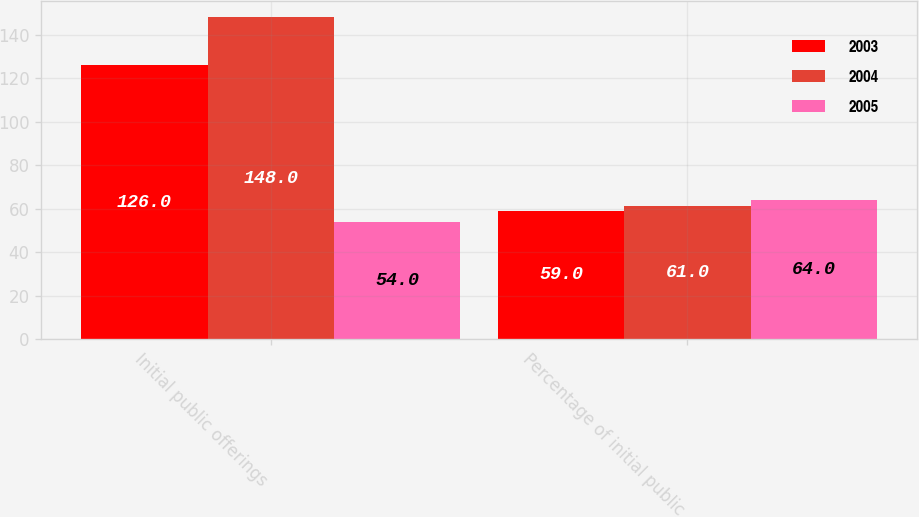Convert chart to OTSL. <chart><loc_0><loc_0><loc_500><loc_500><stacked_bar_chart><ecel><fcel>Initial public offerings<fcel>Percentage of initial public<nl><fcel>2003<fcel>126<fcel>59<nl><fcel>2004<fcel>148<fcel>61<nl><fcel>2005<fcel>54<fcel>64<nl></chart> 